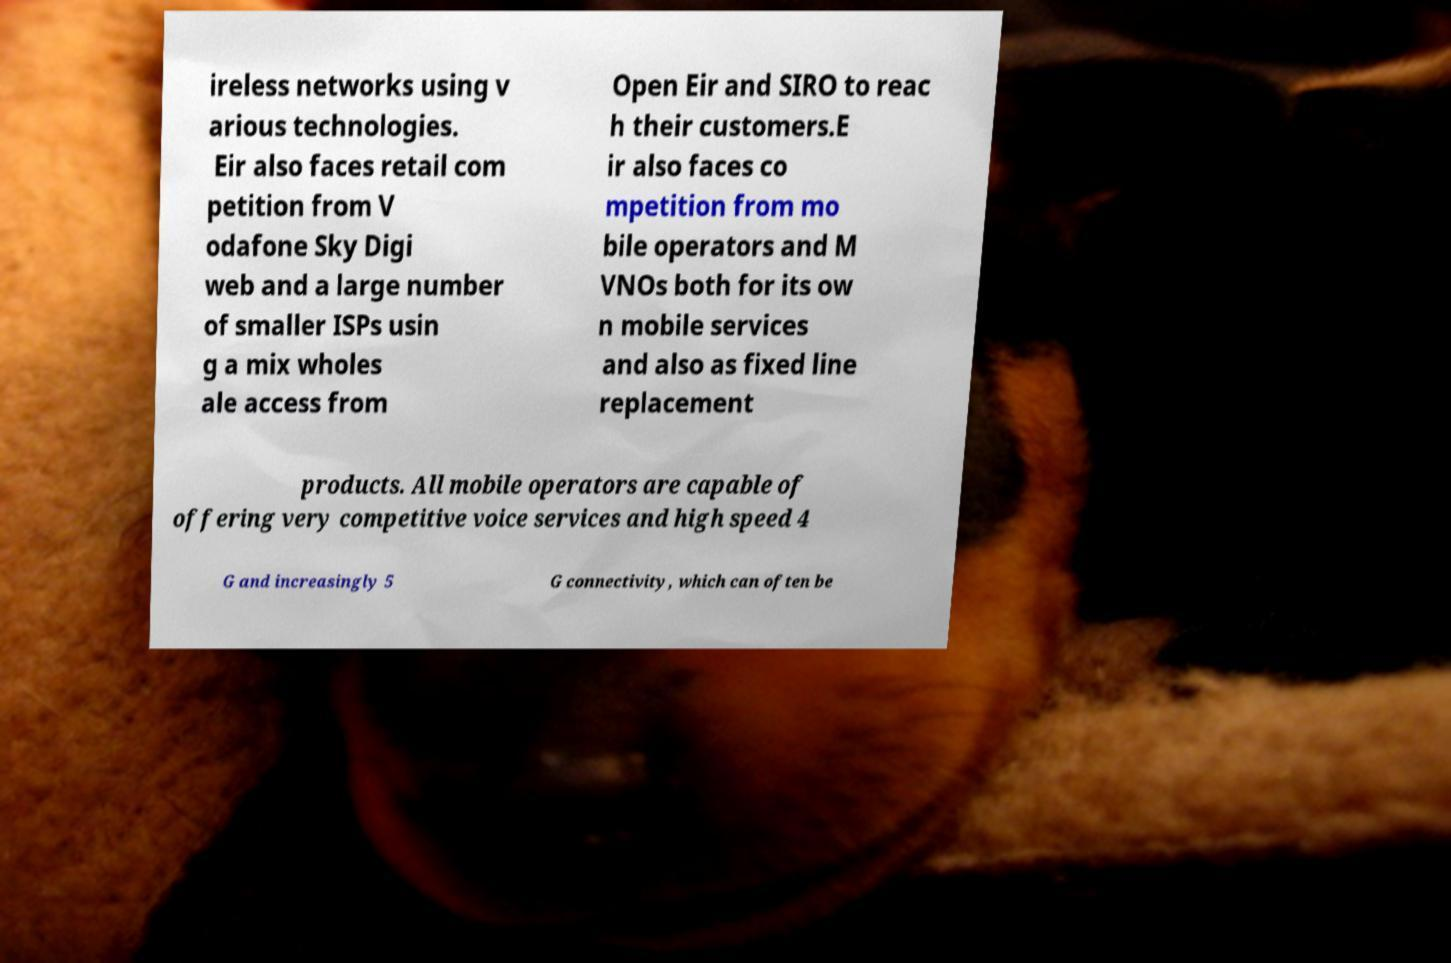What messages or text are displayed in this image? I need them in a readable, typed format. ireless networks using v arious technologies. Eir also faces retail com petition from V odafone Sky Digi web and a large number of smaller ISPs usin g a mix wholes ale access from Open Eir and SIRO to reac h their customers.E ir also faces co mpetition from mo bile operators and M VNOs both for its ow n mobile services and also as fixed line replacement products. All mobile operators are capable of offering very competitive voice services and high speed 4 G and increasingly 5 G connectivity, which can often be 